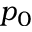<formula> <loc_0><loc_0><loc_500><loc_500>p _ { 0 }</formula> 